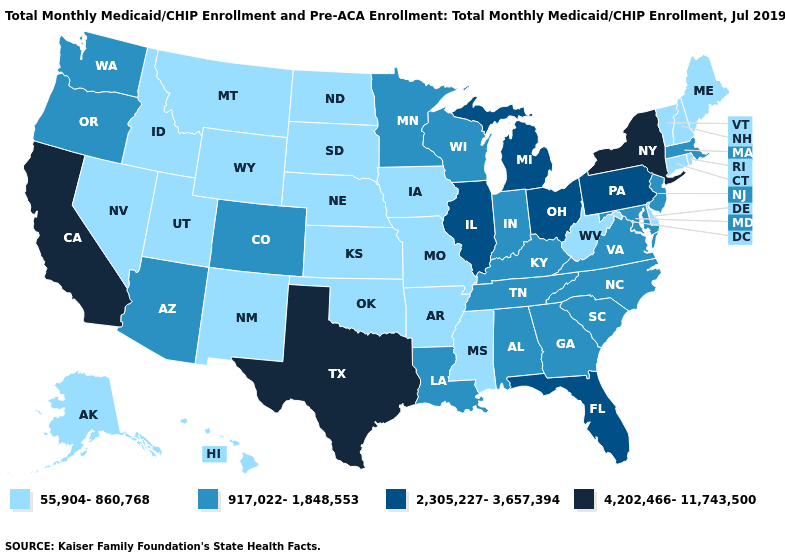Does Vermont have a lower value than Oklahoma?
Be succinct. No. What is the value of Illinois?
Be succinct. 2,305,227-3,657,394. What is the value of California?
Give a very brief answer. 4,202,466-11,743,500. Name the states that have a value in the range 4,202,466-11,743,500?
Quick response, please. California, New York, Texas. Does Montana have a higher value than Minnesota?
Concise answer only. No. What is the lowest value in the USA?
Write a very short answer. 55,904-860,768. Name the states that have a value in the range 55,904-860,768?
Answer briefly. Alaska, Arkansas, Connecticut, Delaware, Hawaii, Idaho, Iowa, Kansas, Maine, Mississippi, Missouri, Montana, Nebraska, Nevada, New Hampshire, New Mexico, North Dakota, Oklahoma, Rhode Island, South Dakota, Utah, Vermont, West Virginia, Wyoming. What is the value of Kentucky?
Short answer required. 917,022-1,848,553. Does Pennsylvania have a higher value than Illinois?
Be succinct. No. Does New York have the highest value in the Northeast?
Answer briefly. Yes. Which states have the lowest value in the MidWest?
Give a very brief answer. Iowa, Kansas, Missouri, Nebraska, North Dakota, South Dakota. Does Hawaii have the same value as Kansas?
Answer briefly. Yes. What is the lowest value in states that border Oklahoma?
Answer briefly. 55,904-860,768. Among the states that border New York , does Connecticut have the lowest value?
Keep it brief. Yes. 